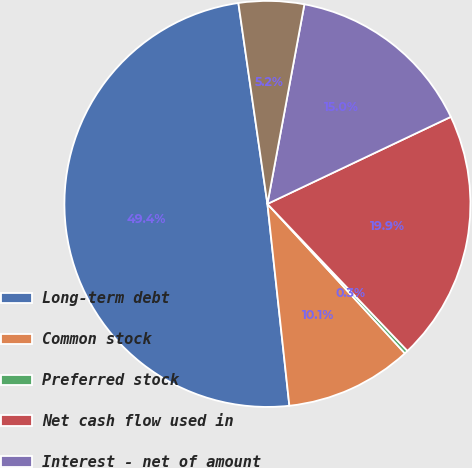Convert chart to OTSL. <chart><loc_0><loc_0><loc_500><loc_500><pie_chart><fcel>Long-term debt<fcel>Common stock<fcel>Preferred stock<fcel>Net cash flow used in<fcel>Interest - net of amount<fcel>Income taxes<nl><fcel>49.44%<fcel>10.11%<fcel>0.28%<fcel>19.94%<fcel>15.03%<fcel>5.2%<nl></chart> 